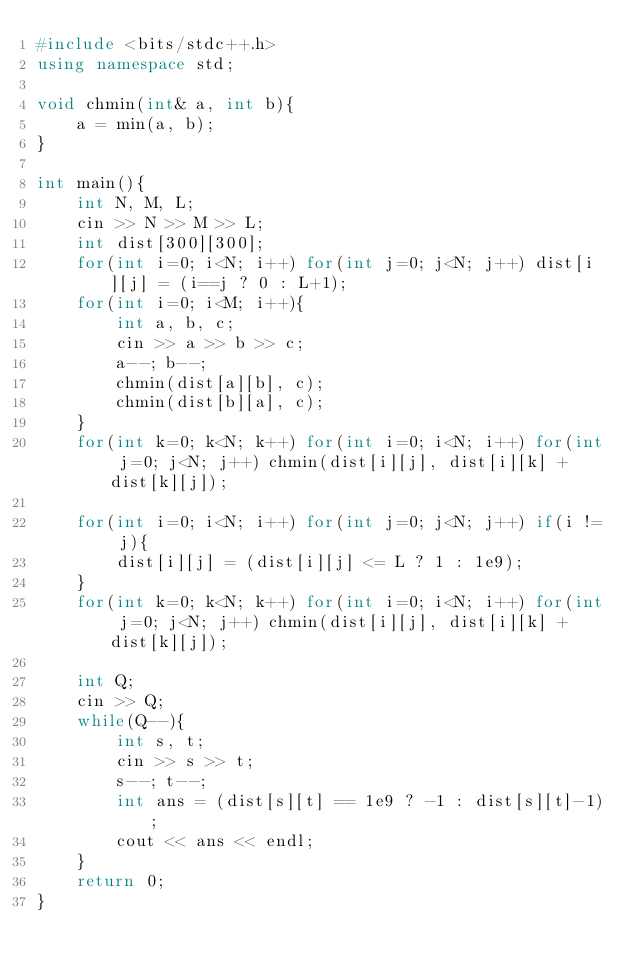<code> <loc_0><loc_0><loc_500><loc_500><_C++_>#include <bits/stdc++.h>
using namespace std;

void chmin(int& a, int b){
    a = min(a, b);
}

int main(){
    int N, M, L;
    cin >> N >> M >> L;
    int dist[300][300];
    for(int i=0; i<N; i++) for(int j=0; j<N; j++) dist[i][j] = (i==j ? 0 : L+1);
    for(int i=0; i<M; i++){
        int a, b, c;
        cin >> a >> b >> c;
        a--; b--;
        chmin(dist[a][b], c);
        chmin(dist[b][a], c);
    }
    for(int k=0; k<N; k++) for(int i=0; i<N; i++) for(int j=0; j<N; j++) chmin(dist[i][j], dist[i][k] + dist[k][j]);

    for(int i=0; i<N; i++) for(int j=0; j<N; j++) if(i != j){
        dist[i][j] = (dist[i][j] <= L ? 1 : 1e9);
    }
    for(int k=0; k<N; k++) for(int i=0; i<N; i++) for(int j=0; j<N; j++) chmin(dist[i][j], dist[i][k] + dist[k][j]);
    
    int Q;
    cin >> Q;
    while(Q--){
        int s, t;
        cin >> s >> t;
        s--; t--;
        int ans = (dist[s][t] == 1e9 ? -1 : dist[s][t]-1);
        cout << ans << endl;
    }
    return 0;
}
</code> 